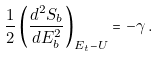<formula> <loc_0><loc_0><loc_500><loc_500>\frac { 1 } { 2 } \left ( \frac { d ^ { 2 } S _ { b } } { d E _ { b } ^ { 2 } } \right ) _ { E _ { t } - U } = - \gamma \, .</formula> 